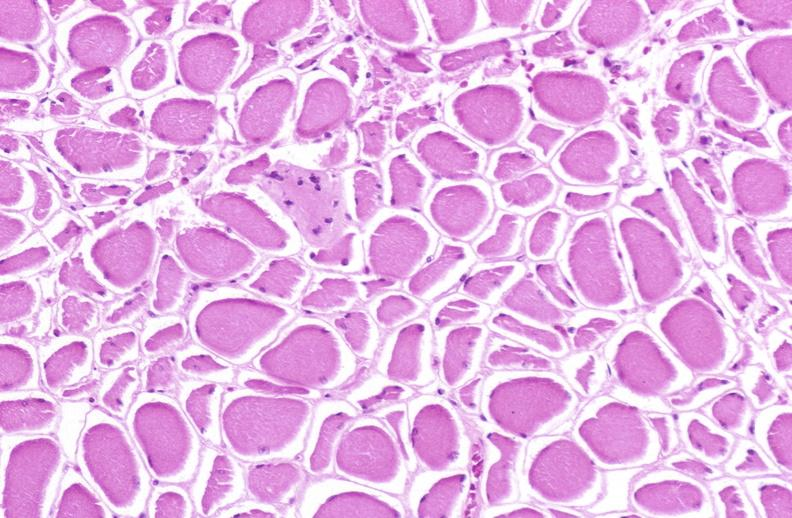does linear fracture in occiput show skeletal muscle atrophy?
Answer the question using a single word or phrase. No 